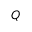<formula> <loc_0><loc_0><loc_500><loc_500>Q</formula> 